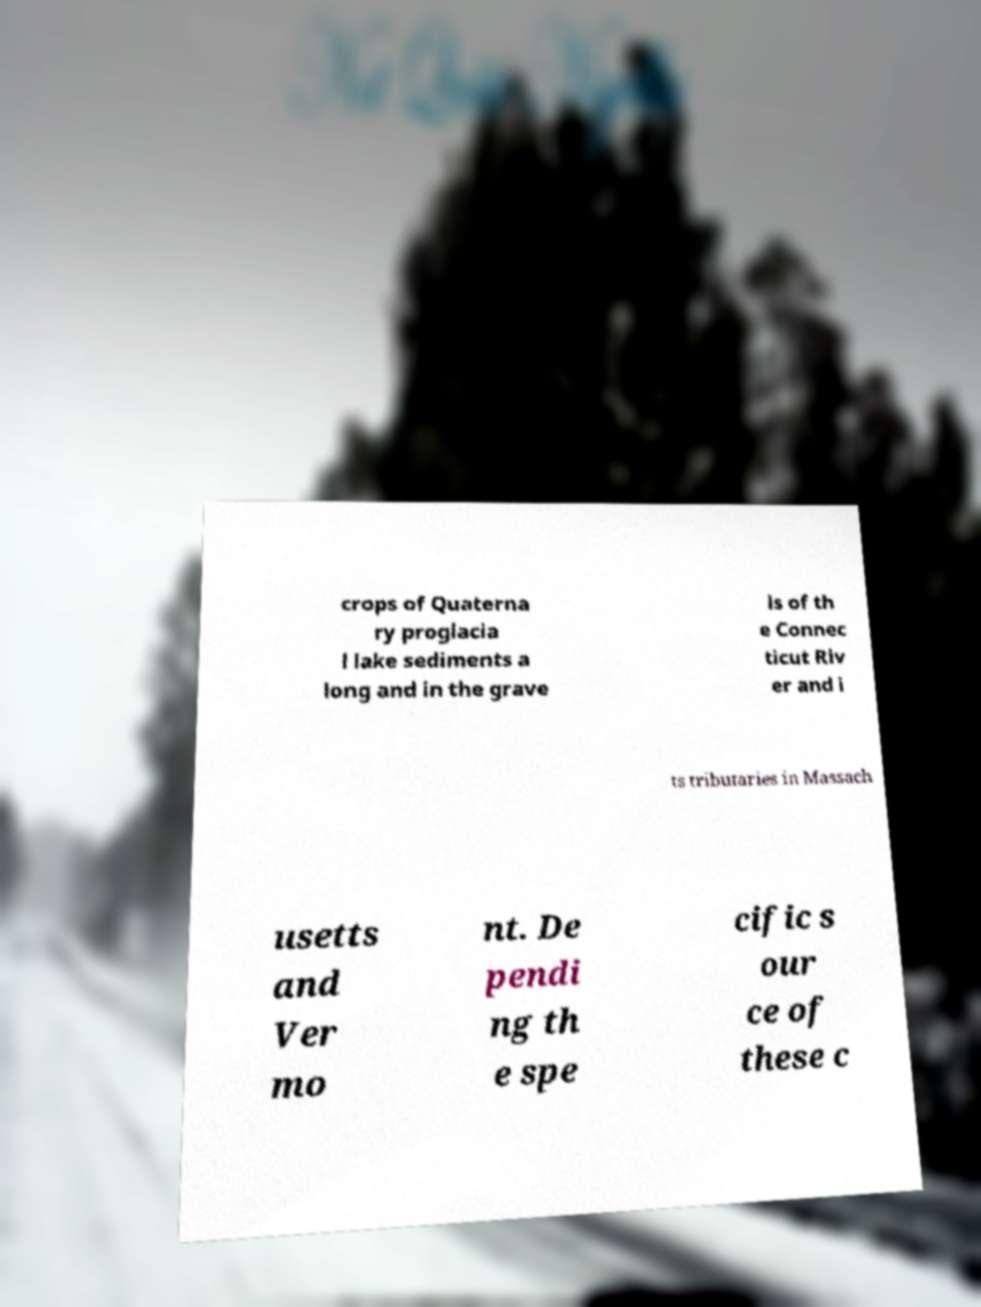Could you extract and type out the text from this image? crops of Quaterna ry proglacia l lake sediments a long and in the grave ls of th e Connec ticut Riv er and i ts tributaries in Massach usetts and Ver mo nt. De pendi ng th e spe cific s our ce of these c 